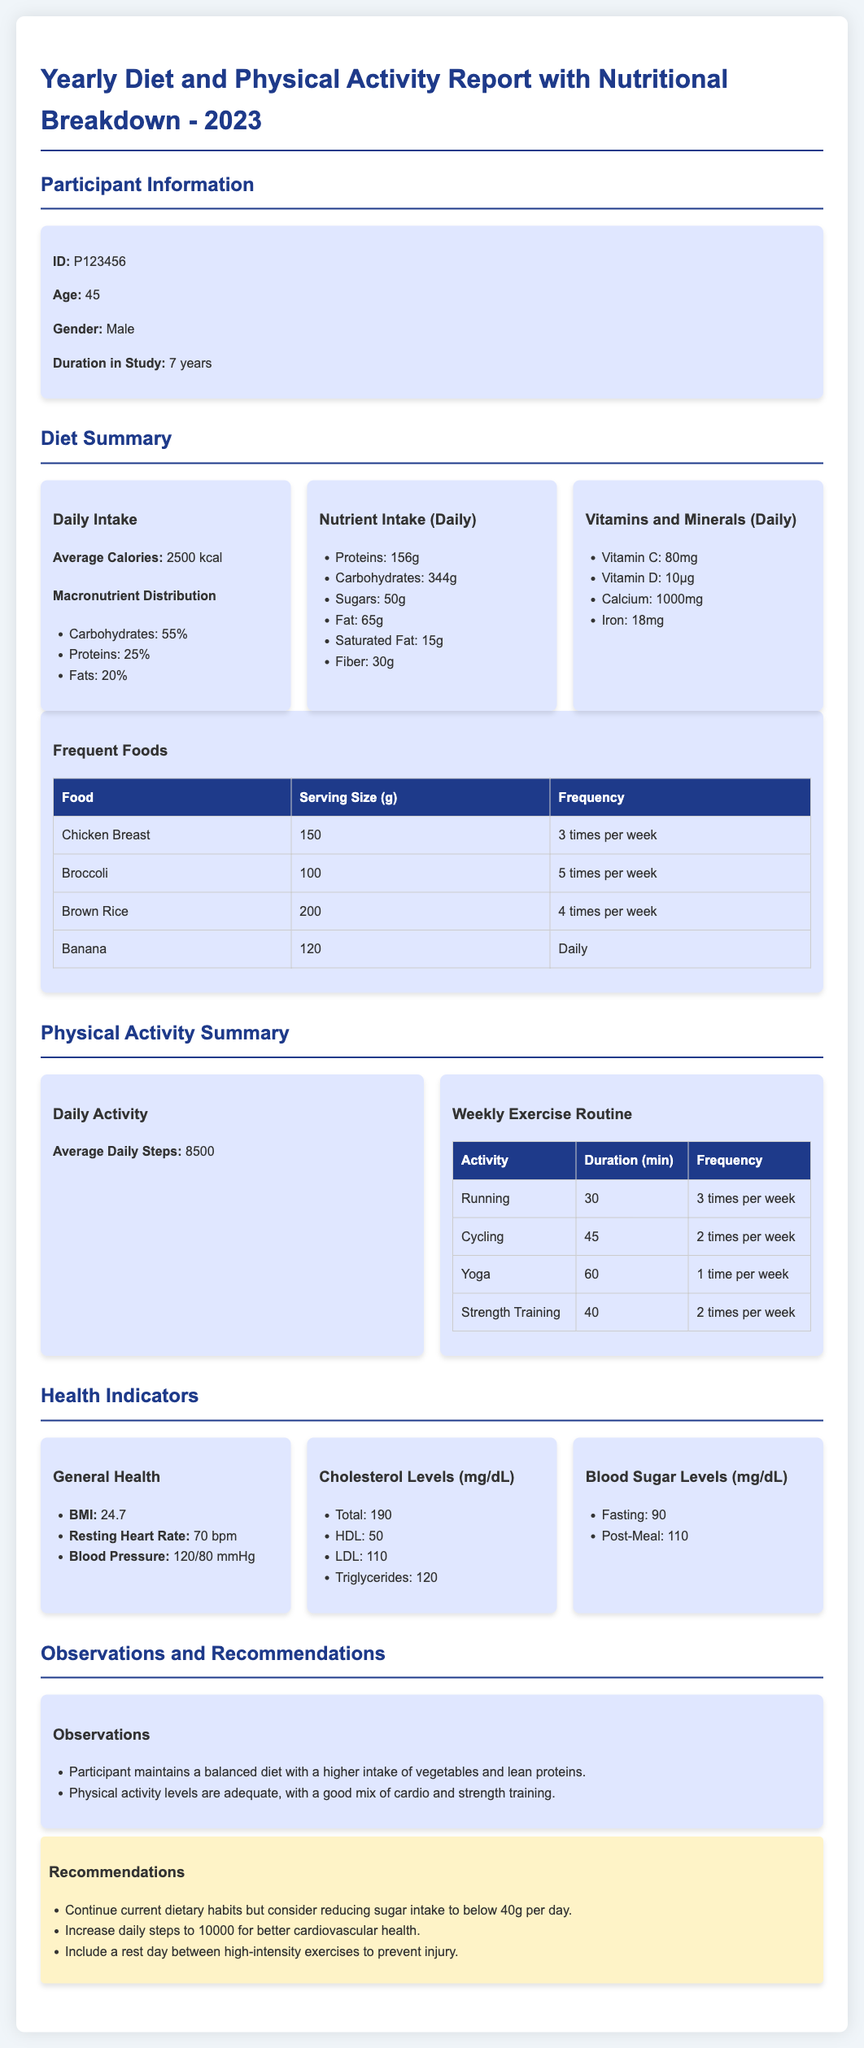What is the participant's ID? The participant's ID is mentioned in the Participant Information section of the document.
Answer: P123456 What is the average daily calorie intake? The average daily calorie intake is provided in the Diet Summary section.
Answer: 2500 kcal How often is chicken breast consumed? The frequency of chicken breast consumption is outlined in the Frequent Foods table.
Answer: 3 times per week What is the average daily step count? The average daily steps are stated in the Physical Activity Summary section.
Answer: 8500 What is the participant's BMI? The BMI is listed under the General Health indicators in the document.
Answer: 24.7 What is the recommended daily sugar intake? The recommendation regarding sugar intake is provided in the Recommendations section.
Answer: below 40g per day Which activity is performed 2 times per week for 40 minutes? The duration and frequency of activities are listed in the Weekly Exercise Routine table.
Answer: Strength Training What is the cholesterol level for HDL? The HDL cholesterol level is found in the Cholesterol Levels section of the Health Indicators.
Answer: 50 How many years has the participant been in the study? The duration in the study is specified in the Participant Information section.
Answer: 7 years 